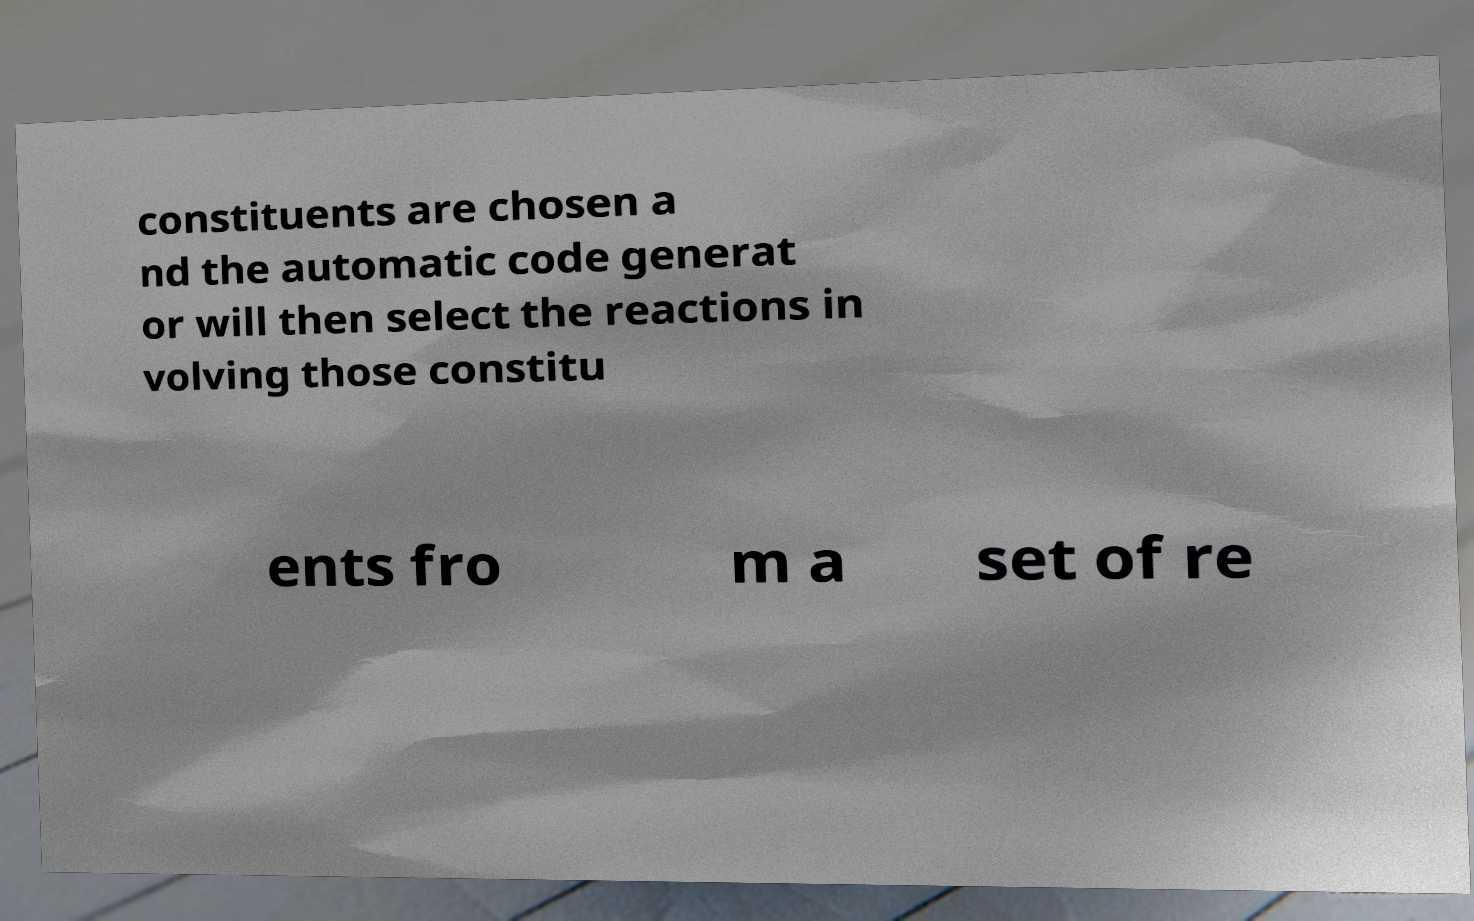Could you extract and type out the text from this image? constituents are chosen a nd the automatic code generat or will then select the reactions in volving those constitu ents fro m a set of re 